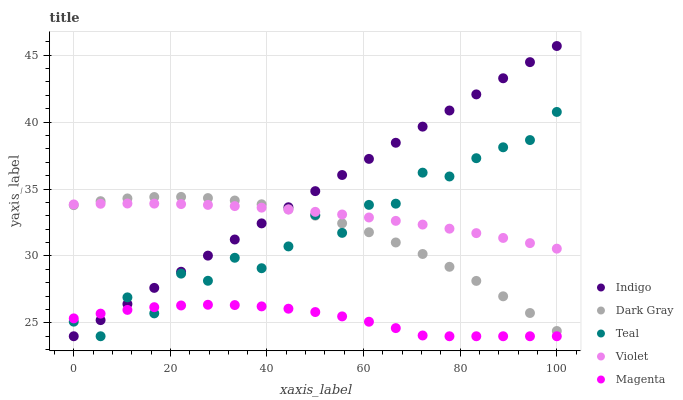Does Magenta have the minimum area under the curve?
Answer yes or no. Yes. Does Indigo have the maximum area under the curve?
Answer yes or no. Yes. Does Indigo have the minimum area under the curve?
Answer yes or no. No. Does Magenta have the maximum area under the curve?
Answer yes or no. No. Is Indigo the smoothest?
Answer yes or no. Yes. Is Teal the roughest?
Answer yes or no. Yes. Is Magenta the smoothest?
Answer yes or no. No. Is Magenta the roughest?
Answer yes or no. No. Does Magenta have the lowest value?
Answer yes or no. Yes. Does Violet have the lowest value?
Answer yes or no. No. Does Indigo have the highest value?
Answer yes or no. Yes. Does Magenta have the highest value?
Answer yes or no. No. Is Magenta less than Violet?
Answer yes or no. Yes. Is Violet greater than Magenta?
Answer yes or no. Yes. Does Indigo intersect Dark Gray?
Answer yes or no. Yes. Is Indigo less than Dark Gray?
Answer yes or no. No. Is Indigo greater than Dark Gray?
Answer yes or no. No. Does Magenta intersect Violet?
Answer yes or no. No. 